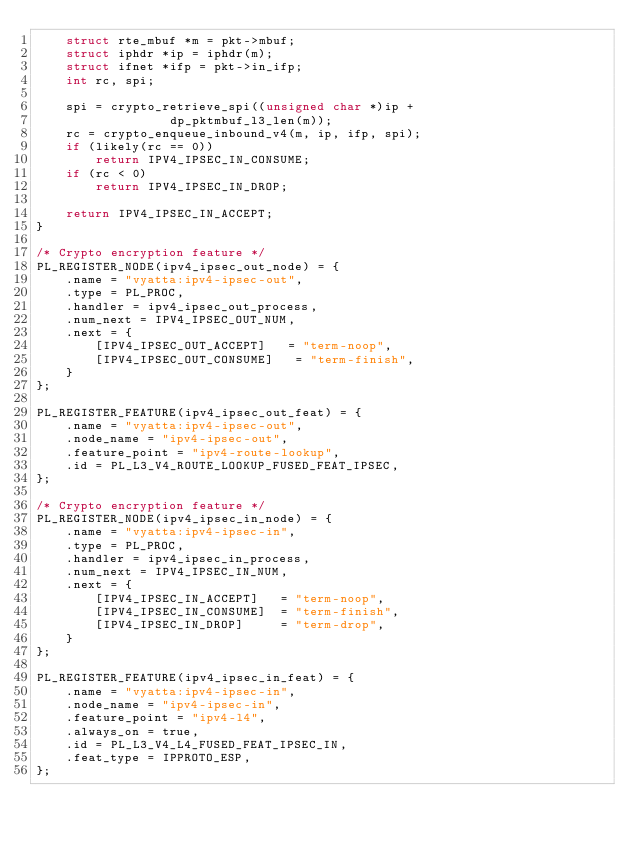<code> <loc_0><loc_0><loc_500><loc_500><_C_>	struct rte_mbuf *m = pkt->mbuf;
	struct iphdr *ip = iphdr(m);
	struct ifnet *ifp = pkt->in_ifp;
	int rc, spi;

	spi = crypto_retrieve_spi((unsigned char *)ip +
				  dp_pktmbuf_l3_len(m));
	rc = crypto_enqueue_inbound_v4(m, ip, ifp, spi);
	if (likely(rc == 0))
		return IPV4_IPSEC_IN_CONSUME;
	if (rc < 0)
		return IPV4_IPSEC_IN_DROP;

	return IPV4_IPSEC_IN_ACCEPT;
}

/* Crypto encryption feature */
PL_REGISTER_NODE(ipv4_ipsec_out_node) = {
	.name = "vyatta:ipv4-ipsec-out",
	.type = PL_PROC,
	.handler = ipv4_ipsec_out_process,
	.num_next = IPV4_IPSEC_OUT_NUM,
	.next = {
		[IPV4_IPSEC_OUT_ACCEPT]   = "term-noop",
		[IPV4_IPSEC_OUT_CONSUME]   = "term-finish",
	}
};

PL_REGISTER_FEATURE(ipv4_ipsec_out_feat) = {
	.name = "vyatta:ipv4-ipsec-out",
	.node_name = "ipv4-ipsec-out",
	.feature_point = "ipv4-route-lookup",
	.id = PL_L3_V4_ROUTE_LOOKUP_FUSED_FEAT_IPSEC,
};

/* Crypto encryption feature */
PL_REGISTER_NODE(ipv4_ipsec_in_node) = {
	.name = "vyatta:ipv4-ipsec-in",
	.type = PL_PROC,
	.handler = ipv4_ipsec_in_process,
	.num_next = IPV4_IPSEC_IN_NUM,
	.next = {
		[IPV4_IPSEC_IN_ACCEPT]   = "term-noop",
		[IPV4_IPSEC_IN_CONSUME]  = "term-finish",
		[IPV4_IPSEC_IN_DROP]     = "term-drop",
	}
};

PL_REGISTER_FEATURE(ipv4_ipsec_in_feat) = {
	.name = "vyatta:ipv4-ipsec-in",
	.node_name = "ipv4-ipsec-in",
	.feature_point = "ipv4-l4",
	.always_on = true,
	.id = PL_L3_V4_L4_FUSED_FEAT_IPSEC_IN,
	.feat_type = IPPROTO_ESP,
};
</code> 